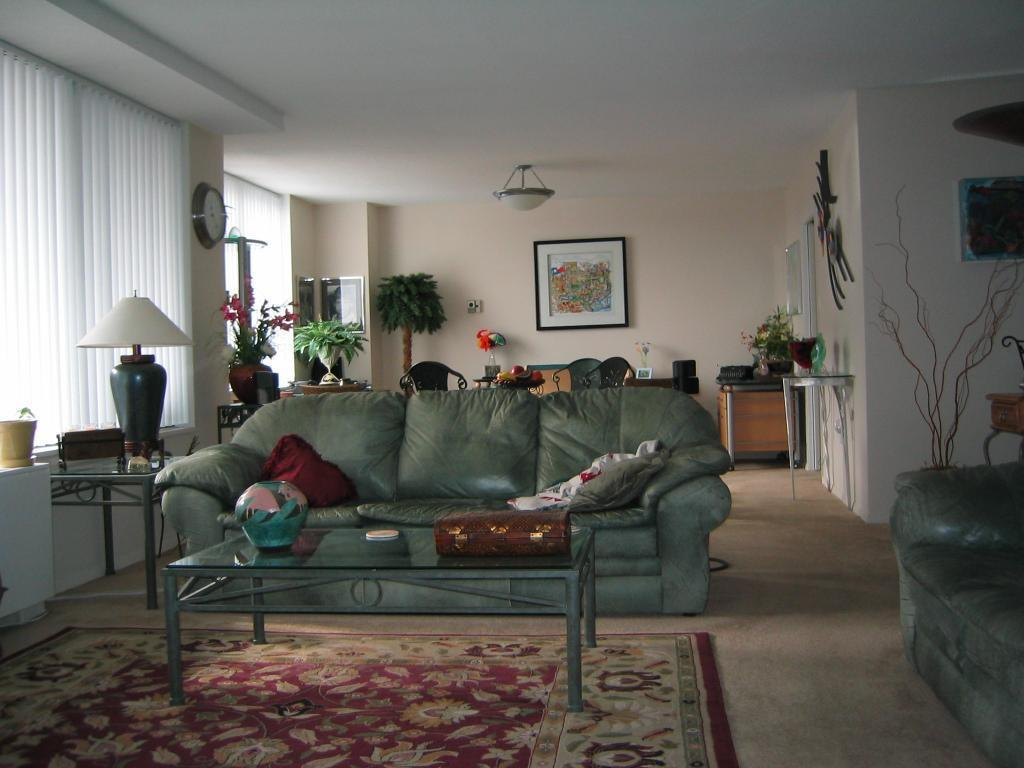What type of furniture is present in the image? There is a sofa and a desk in the image. What is on top of the desk? There is a lamp on the desk. What can be seen on the wall in the image? There are frames on the wall. What color is the brick in the middle of the image? There is no brick present in the image. 